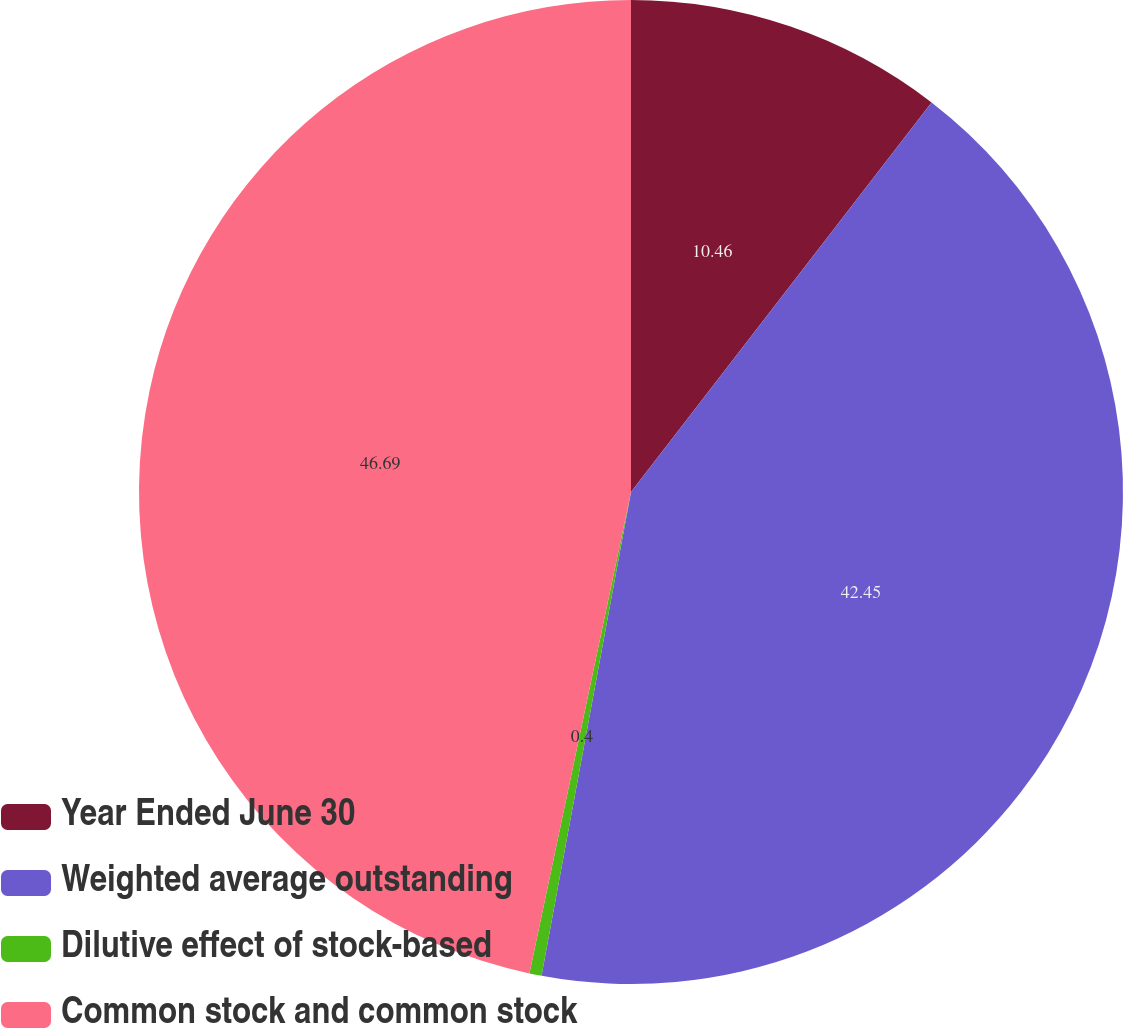Convert chart to OTSL. <chart><loc_0><loc_0><loc_500><loc_500><pie_chart><fcel>Year Ended June 30<fcel>Weighted average outstanding<fcel>Dilutive effect of stock-based<fcel>Common stock and common stock<nl><fcel>10.46%<fcel>42.45%<fcel>0.4%<fcel>46.69%<nl></chart> 